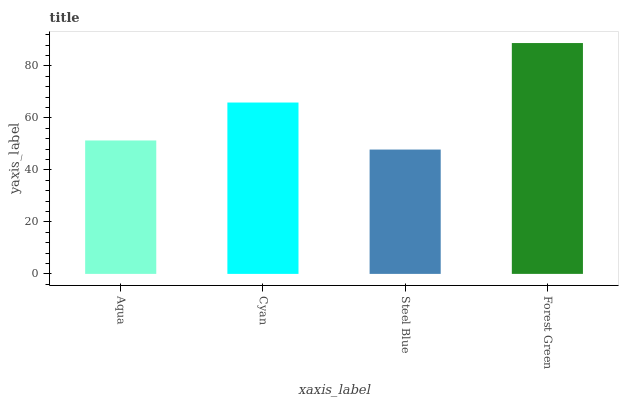Is Cyan the minimum?
Answer yes or no. No. Is Cyan the maximum?
Answer yes or no. No. Is Cyan greater than Aqua?
Answer yes or no. Yes. Is Aqua less than Cyan?
Answer yes or no. Yes. Is Aqua greater than Cyan?
Answer yes or no. No. Is Cyan less than Aqua?
Answer yes or no. No. Is Cyan the high median?
Answer yes or no. Yes. Is Aqua the low median?
Answer yes or no. Yes. Is Forest Green the high median?
Answer yes or no. No. Is Cyan the low median?
Answer yes or no. No. 